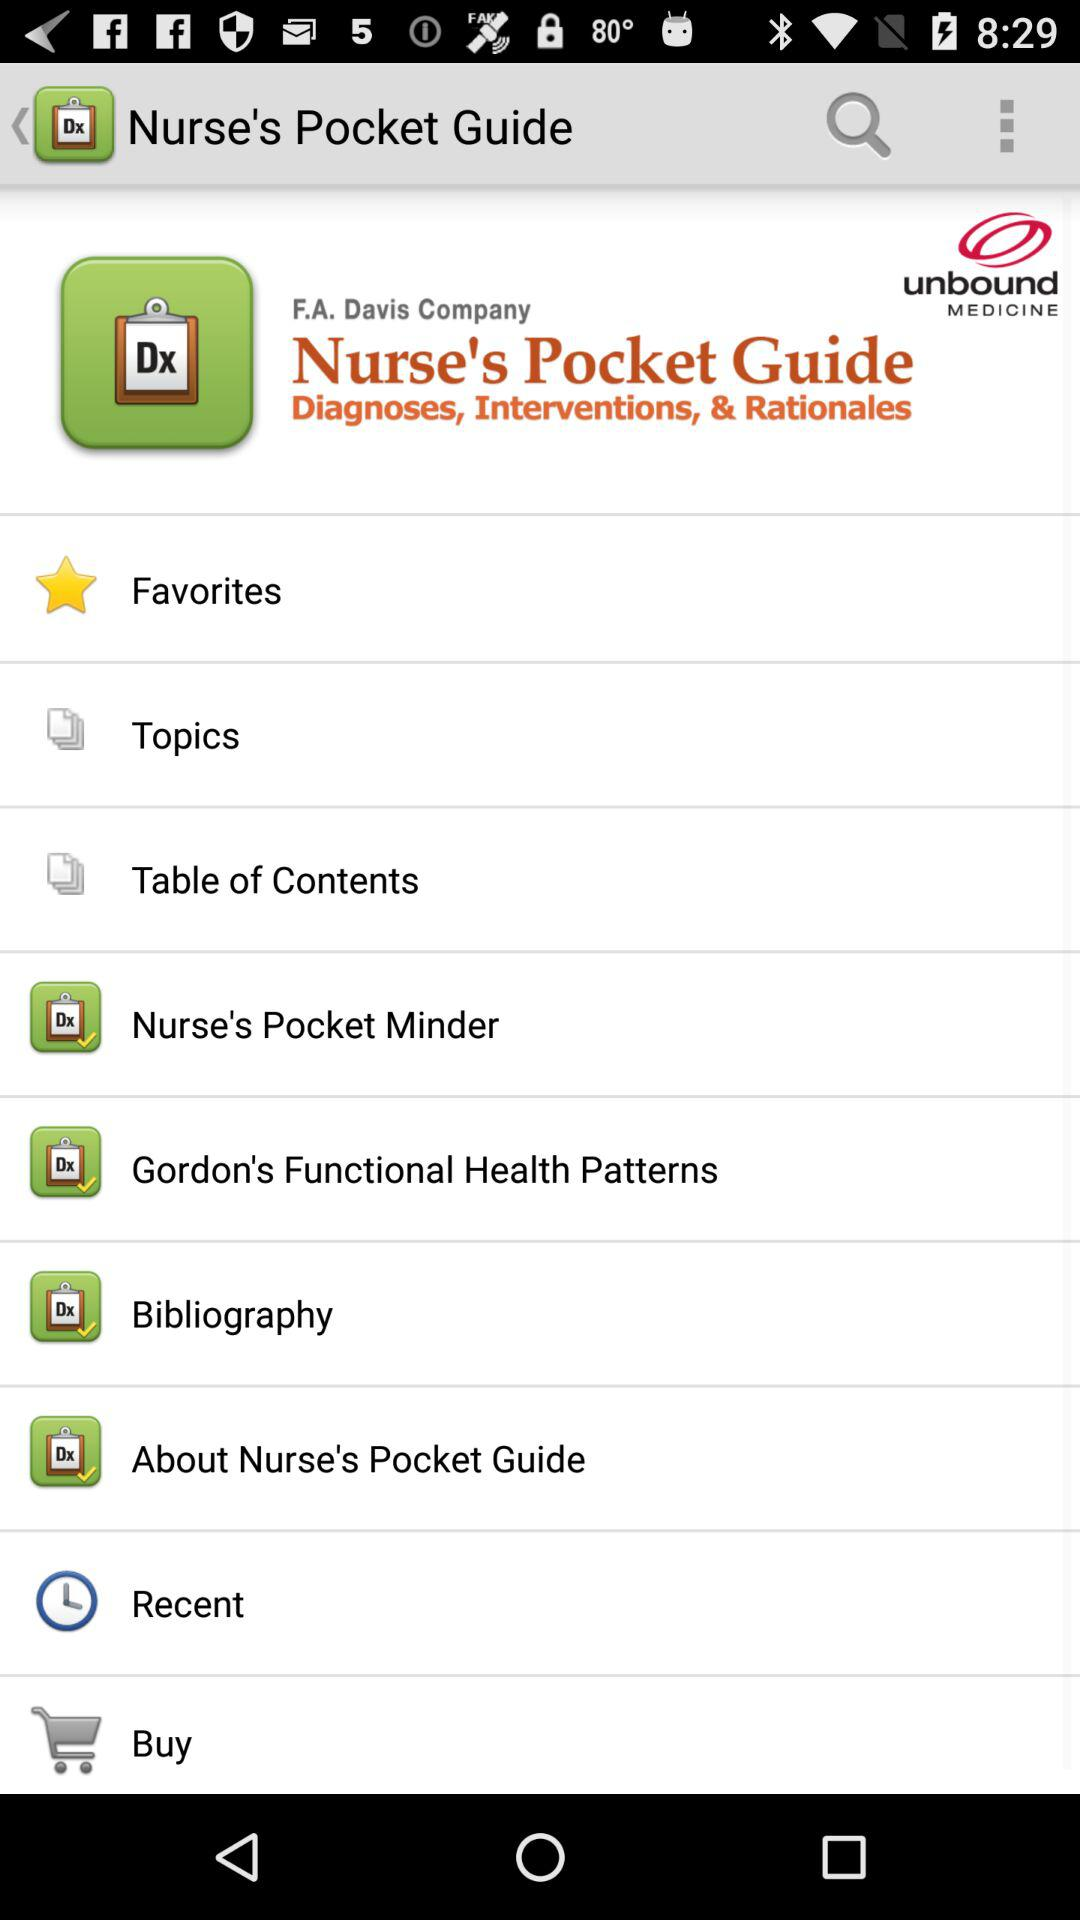What is the company name? The company names are "F.A. Davis Company" and "unbound MEDICINE". 